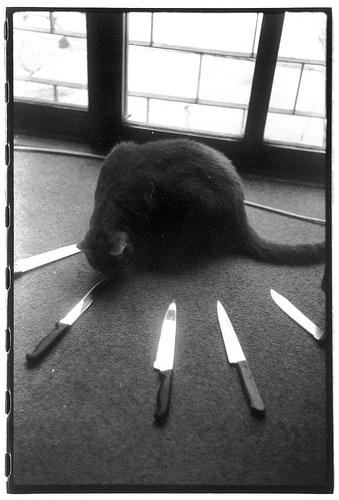What is surrounding the cat? Please explain your reasoning. knives. There are sharp metal blades on the floor 